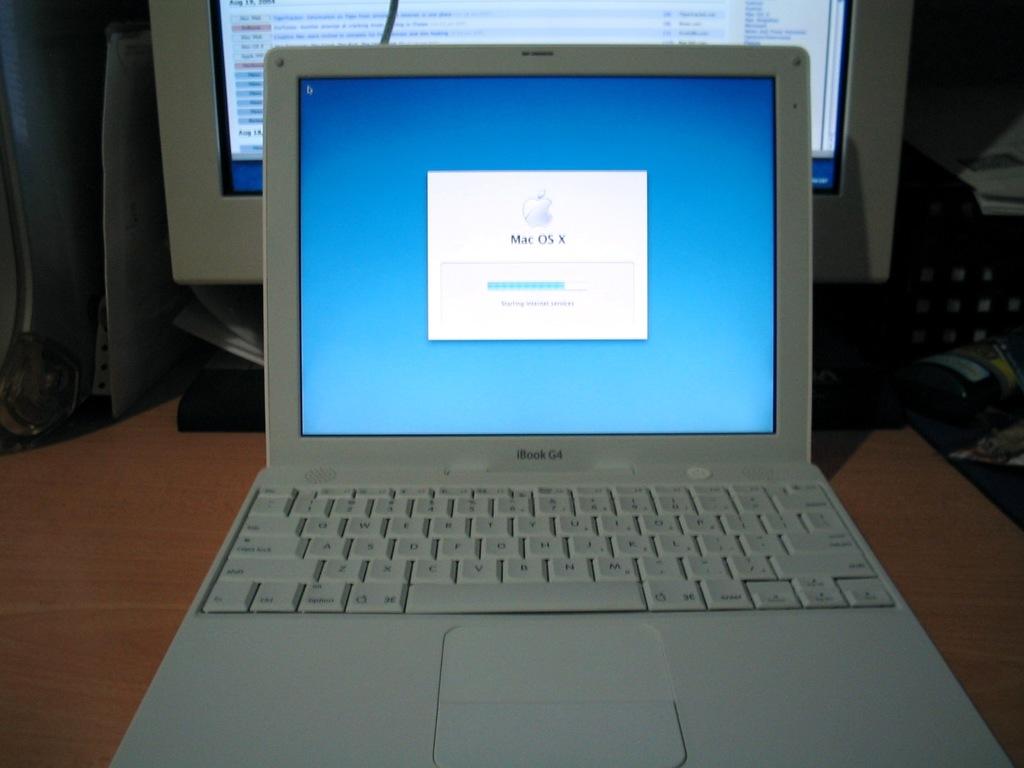What mac os number is on this computer?
Offer a very short reply. X. Is this an ibookg4?
Ensure brevity in your answer.  Yes. 